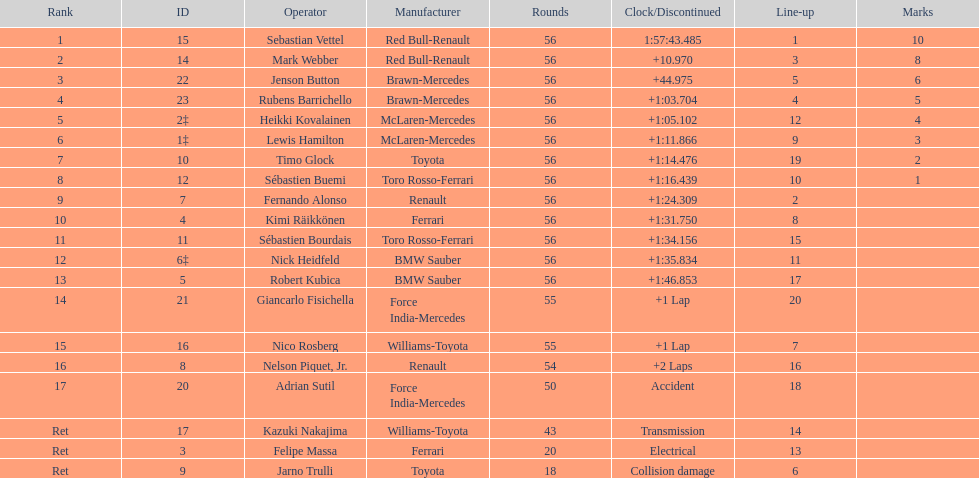Heikki kovalainen and lewis hamilton both had which constructor? McLaren-Mercedes. 